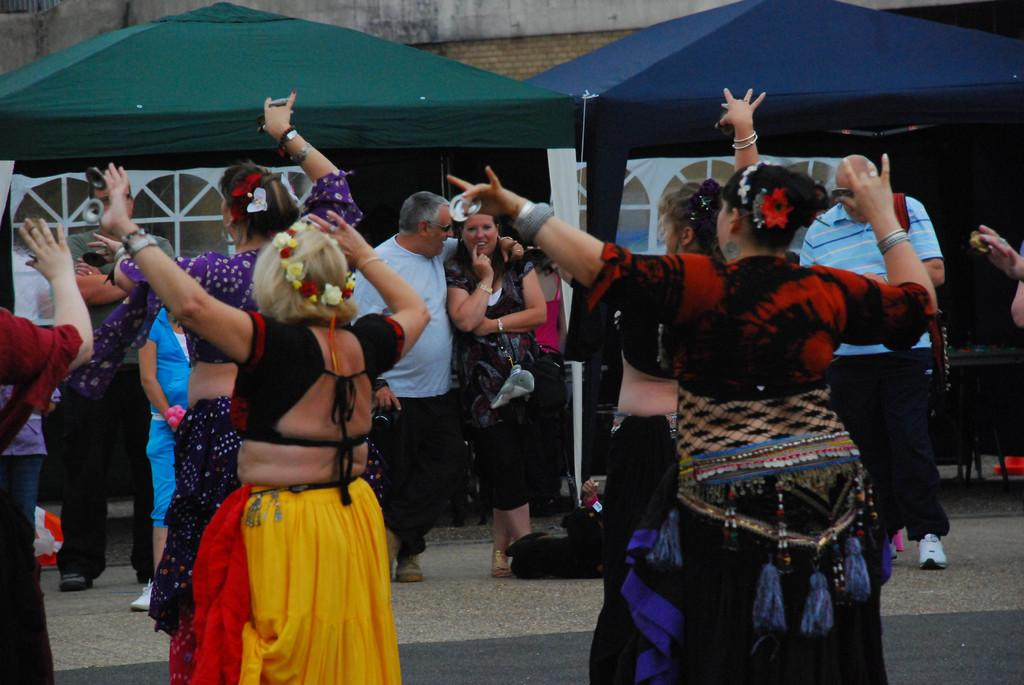What are the people in the image doing? The people in the image are standing on the road. What are some of the people wearing? Some of the people are wearing costumes. What can be seen in the background of the image? There are tents and buildings in the background of the image. What type of belief can be seen in the image? There is no indication of any belief in the image. --- Facts: 1. There is a person in the image. 2. The person is holding a book. 3. The book has a blue cover. 4. The person is sitting on a chair. 5. There is a table next to the person. Absurd Topics: unicorn, rainbow, magic wand Conversation: Who or what is in the image? There is a person in the image. What is the person holding? The person is holding a book. Can you describe the book? The book has a blue cover. What is the person's position in the image? The person is sitting on a chair. Is there any furniture near the person? Yes, there is a table next to the person. Reasoning: Let's think step by step in order to produce the conversation. We start by identifying the main subject in the image, which is the person. Then, we describe what the person is holding, which is a book. Next, we provide a description of the book, mentioning that it has a blue cover. After that, we observe the person's position in the image, which is sitting on a chair. Finally, we acknowledge the presence of any other furniture near the person, which in this case is a table next to the person. Absurd Question/Answer: Can you see a unicorn in the image? No, there is no unicorn present in the image. --- Facts: 1. There is a dog in the image. 2. The dog is lying down on the grass. 3. There is a tree in the background of the image. 4. The sky is visible in the image. Absurd Topics: spaceship, alien, galaxy Conversation: What type of animal is in the image? There is a dog in the image. What is the dog doing in the image? The dog is lying down on the grass. What can be seen in the background of the image? There is a tree in the background of the image. What part of the natural environment is visible in the image? The sky is visible in the image. Reasoning: Let's think step by step in order to produce the conversation. We start by identifying the main subject in the image, which is the dog. Then, we describe what the dog is doing in the image, which is lying down on the grass. Next, we expand the conversation to include the background of the image, which includes a tree. Finally, we describe the 